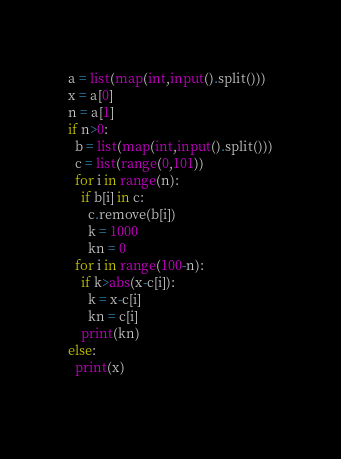<code> <loc_0><loc_0><loc_500><loc_500><_Python_>a = list(map(int,input().split()))
x = a[0]
n = a[1]
if n>0:
  b = list(map(int,input().split()))
  c = list(range(0,101))
  for i in range(n):
    if b[i] in c:
      c.remove(b[i])
      k = 1000
      kn = 0
  for i in range(100-n):
    if k>abs(x-c[i]):
      k = x-c[i]
      kn = c[i]
    print(kn)
else:
  print(x)
  </code> 